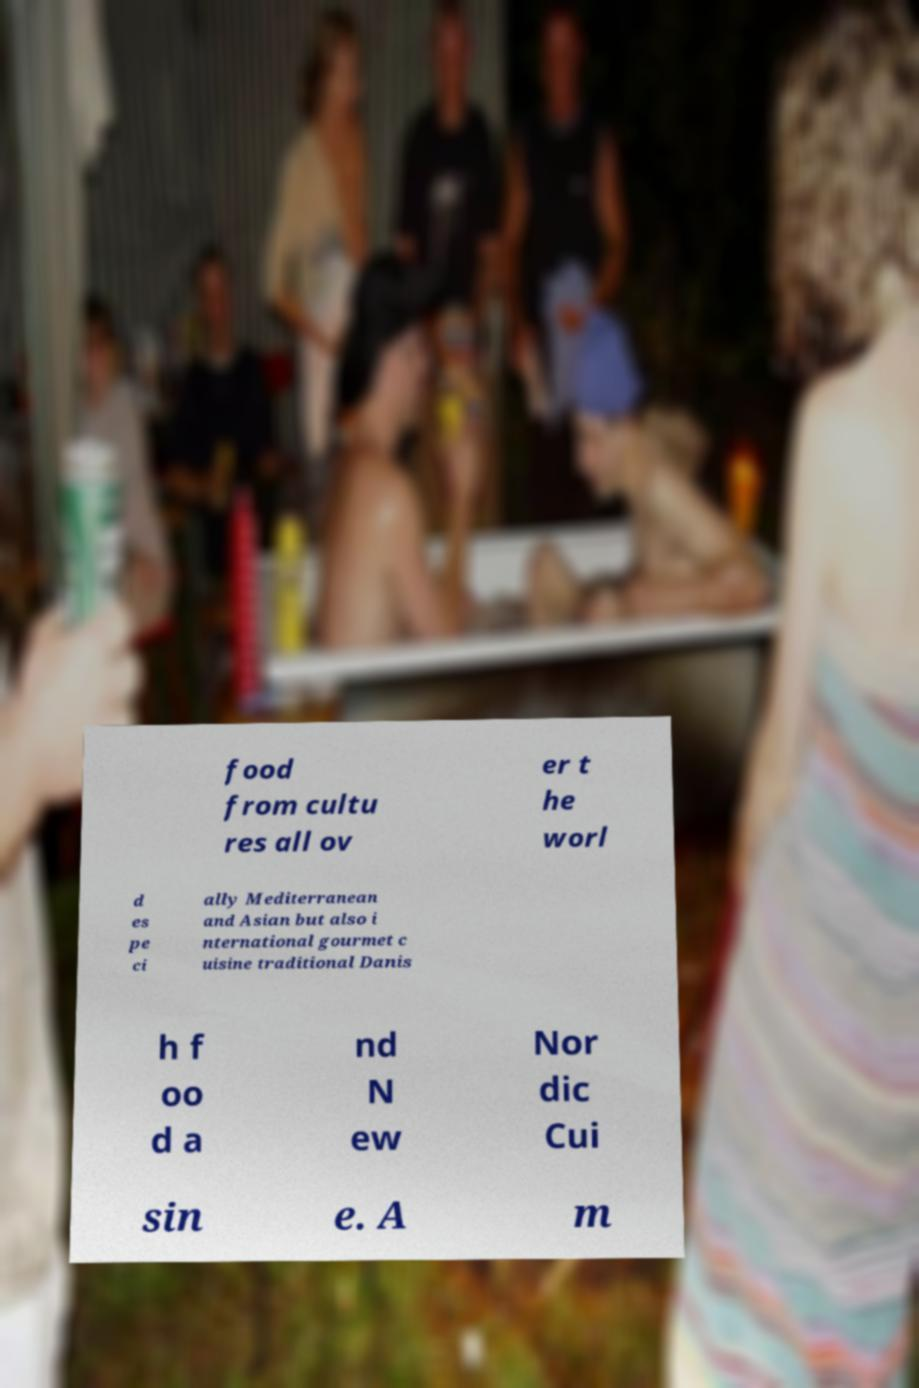There's text embedded in this image that I need extracted. Can you transcribe it verbatim? food from cultu res all ov er t he worl d es pe ci ally Mediterranean and Asian but also i nternational gourmet c uisine traditional Danis h f oo d a nd N ew Nor dic Cui sin e. A m 